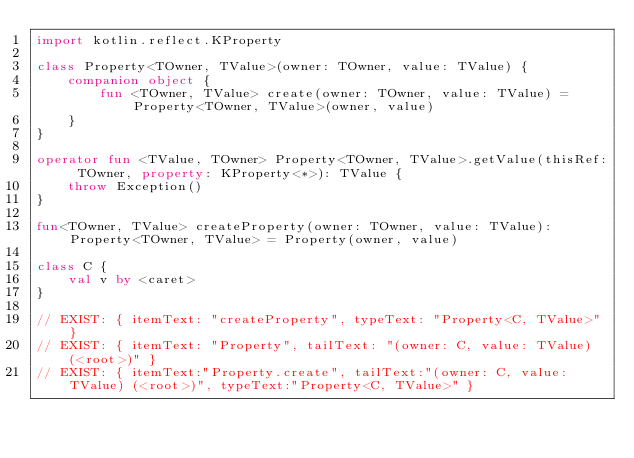Convert code to text. <code><loc_0><loc_0><loc_500><loc_500><_Kotlin_>import kotlin.reflect.KProperty

class Property<TOwner, TValue>(owner: TOwner, value: TValue) {
    companion object {
        fun <TOwner, TValue> create(owner: TOwner, value: TValue) = Property<TOwner, TValue>(owner, value)
    }
}

operator fun <TValue, TOwner> Property<TOwner, TValue>.getValue(thisRef: TOwner, property: KProperty<*>): TValue {
    throw Exception()
}

fun<TOwner, TValue> createProperty(owner: TOwner, value: TValue): Property<TOwner, TValue> = Property(owner, value)

class C {
    val v by <caret>
}

// EXIST: { itemText: "createProperty", typeText: "Property<C, TValue>" }
// EXIST: { itemText: "Property", tailText: "(owner: C, value: TValue) (<root>)" }
// EXIST: { itemText:"Property.create", tailText:"(owner: C, value: TValue) (<root>)", typeText:"Property<C, TValue>" }
</code> 